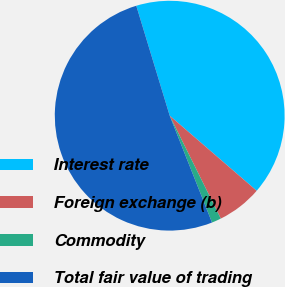Convert chart to OTSL. <chart><loc_0><loc_0><loc_500><loc_500><pie_chart><fcel>Interest rate<fcel>Foreign exchange (b)<fcel>Commodity<fcel>Total fair value of trading<nl><fcel>41.03%<fcel>6.33%<fcel>1.33%<fcel>51.3%<nl></chart> 